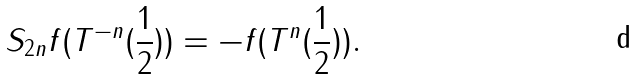Convert formula to latex. <formula><loc_0><loc_0><loc_500><loc_500>S _ { 2 n } f ( T ^ { - n } ( \frac { 1 } { 2 } ) ) = - f ( T ^ { n } ( \frac { 1 } { 2 } ) ) .</formula> 